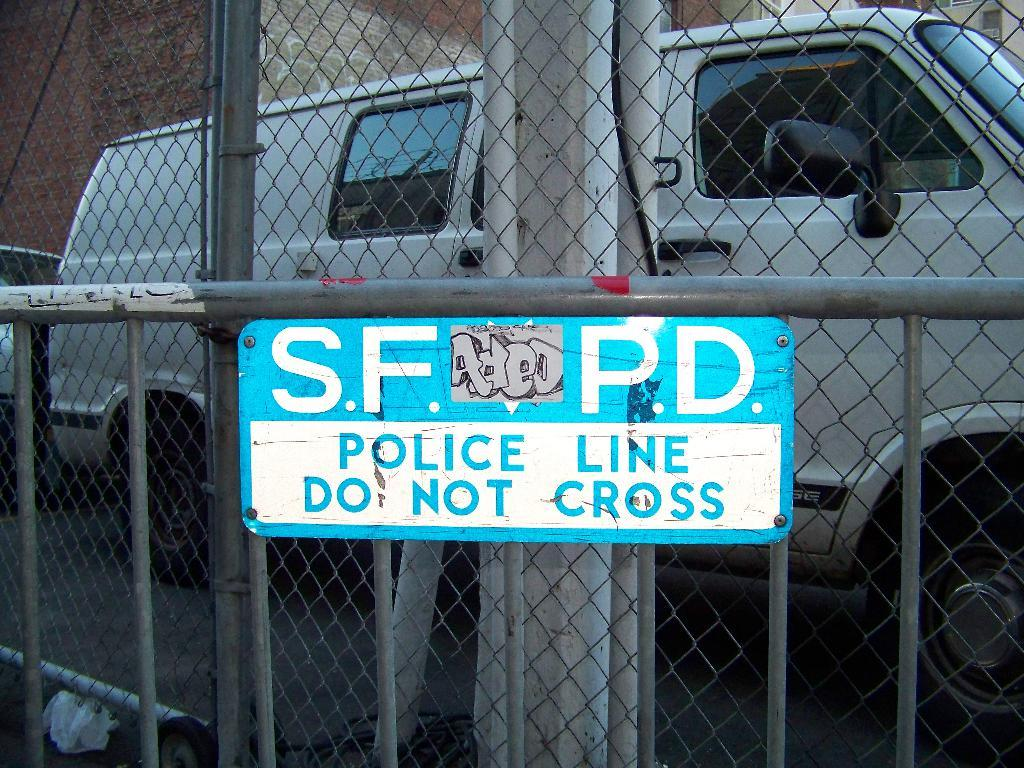What type of barrier can be seen in the image? There is a fence in the image. What is attached to the fence? There is a text board on the fence. What can be seen behind the fence? There is a vehicle on the road behind the fence. What is used to protect or conceal something in the image? There is a cover visible in the image. What type of structure is present in the image? There is a building in the image. What part of a building is visible in the image? There is a building wall visible in the image. What scientific discovery is mentioned on the receipt in the image? There is no receipt present in the image, and therefore no scientific discovery can be mentioned. What impulse is the vehicle experiencing in the image? The image does not provide information about the vehicle's impulses, and therefore we cannot determine what impulse it might be experiencing. 